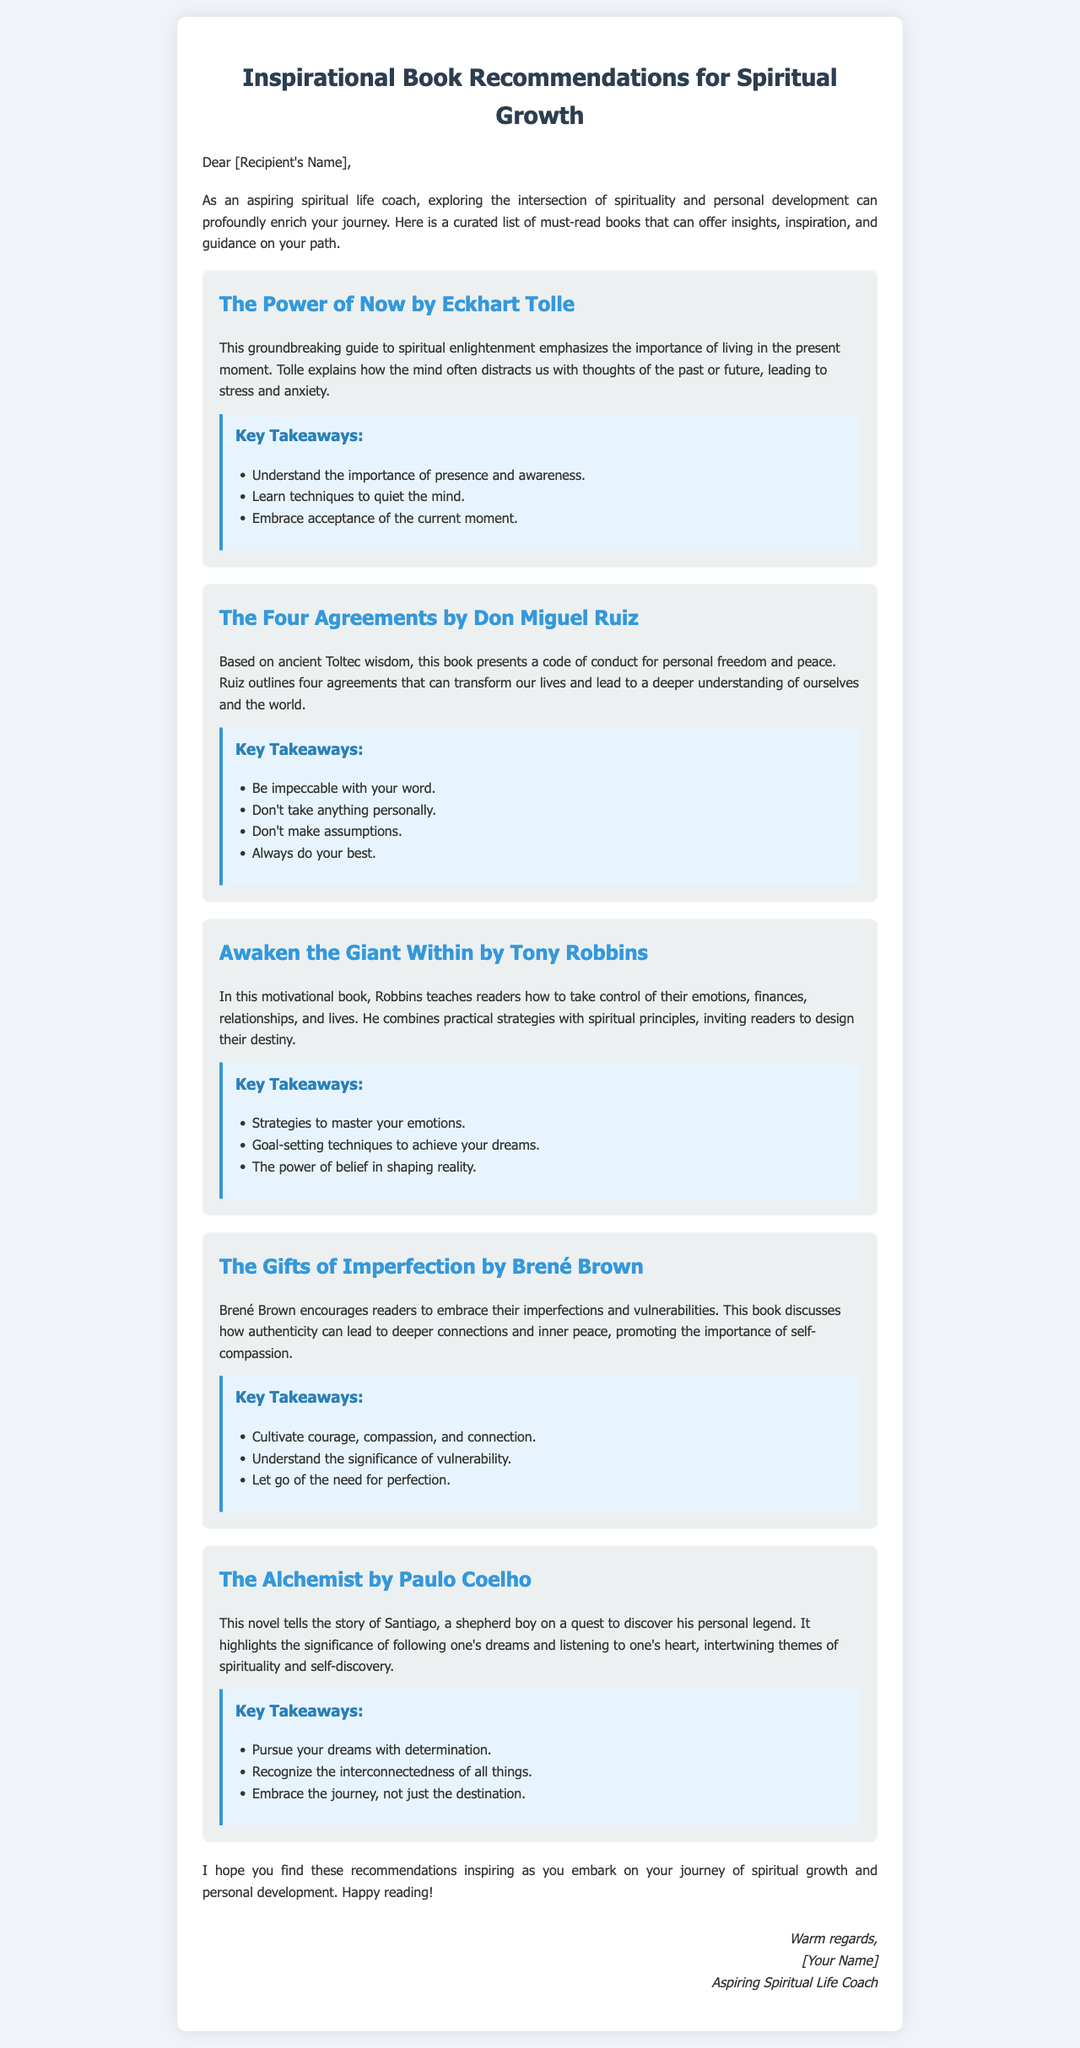what is the title of the first book recommended? The first book is listed under the title section of the document.
Answer: The Power of Now who is the author of "The Four Agreements"? The author is mentioned right after the book title.
Answer: Don Miguel Ruiz how many key takeaways are provided for "The Gifts of Imperfection"? The number of key takeaways can be found in the key takeaways section for that book.
Answer: Three what theme does "The Alchemist" primarily focus on? The theme is described in the summary of the book within the document.
Answer: Following one's dreams who recommends these books? The person who wrote the introduction section states who they are in the signature.
Answer: Aspiring Spiritual Life Coach what emotion does Brené Brown encourage readers to embrace? The emotion is discussed in the summary of her book.
Answer: Vulnerability how should readers interpret their dreams according to Tony Robbins? The interpretation of dreams is found in the key takeaways of Robbins' book.
Answer: As a means to shape reality which book emphasizes living in the present moment? The emphasis is stated in the summary of the respective book.
Answer: The Power of Now 